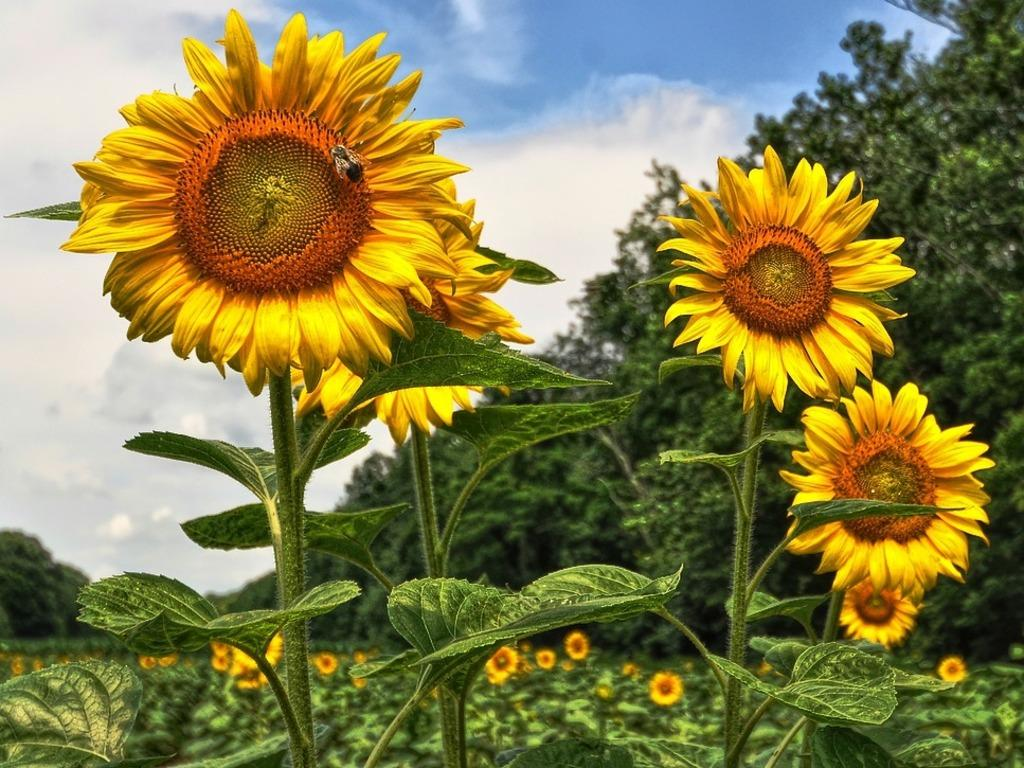What type of flowers are in the image? There are sunflowers in thes in the image. What can be seen in the background of the image? There are trees in the background of the image. What type of tool is being used to tighten the cord in the image? There is no tool or cord present in the image; it features sunflowers and trees in the background. 